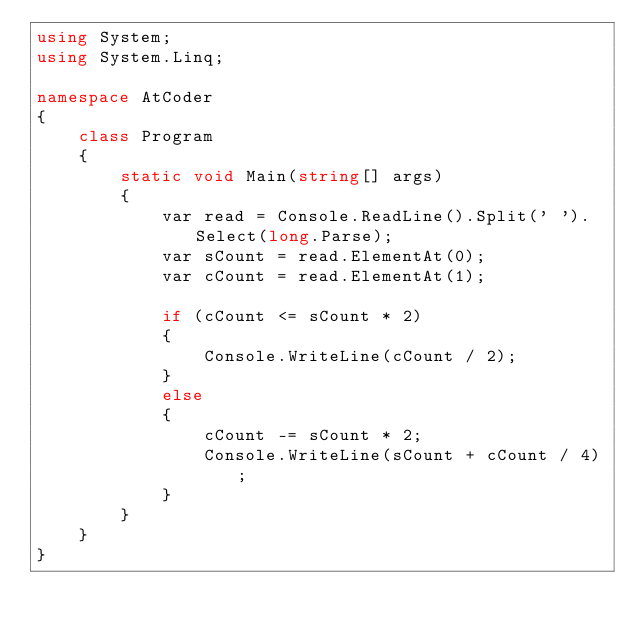Convert code to text. <code><loc_0><loc_0><loc_500><loc_500><_C#_>using System;
using System.Linq;

namespace AtCoder
{
    class Program
    {
        static void Main(string[] args)
        {
            var read = Console.ReadLine().Split(' ').Select(long.Parse);
            var sCount = read.ElementAt(0);
            var cCount = read.ElementAt(1);

            if (cCount <= sCount * 2)
            {
                Console.WriteLine(cCount / 2);
            }
            else
            {
                cCount -= sCount * 2;
                Console.WriteLine(sCount + cCount / 4);
            }
        }
    }
}
</code> 